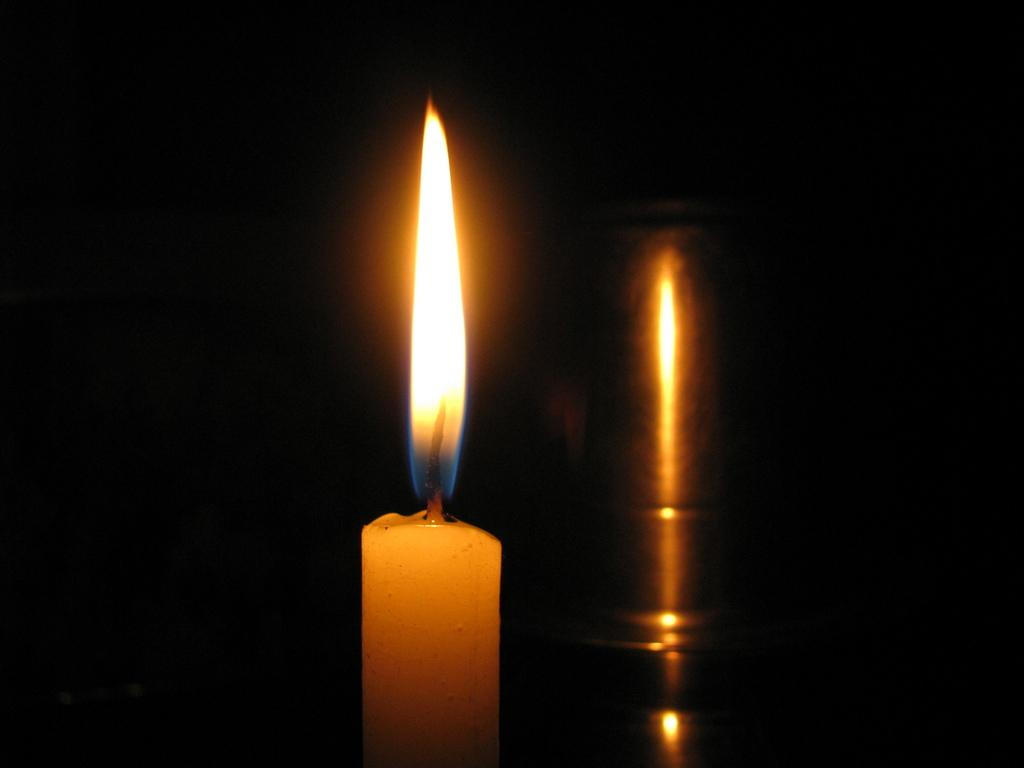What is present in the image that provides light? There is a light associated with the candle in the image. What object is the source of the light in the image? There is a candle in the image that provides the light. Is there any representation of the candle in the image? Yes, there is an image of the candle beside it. How much salt is present in the image? There is no salt present in the image. What type of list is visible in the image? There is no list visible in the image. 